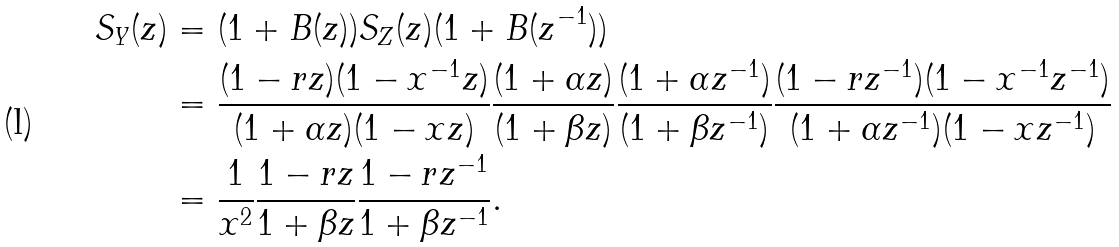<formula> <loc_0><loc_0><loc_500><loc_500>S _ { Y } ( z ) & = ( 1 + B ( z ) ) S _ { Z } ( z ) ( 1 + B ( z ^ { - 1 } ) ) \\ & = \frac { ( 1 - r z ) ( 1 - x ^ { - 1 } z ) } { ( 1 + \alpha z ) ( 1 - x z ) } \frac { ( 1 + \alpha z ) } { ( 1 + \beta z ) } \frac { ( 1 + \alpha z ^ { - 1 } ) } { ( 1 + \beta z ^ { - 1 } ) } \frac { ( 1 - r z ^ { - 1 } ) ( 1 - x ^ { - 1 } z ^ { - 1 } ) } { ( 1 + \alpha z ^ { - 1 } ) ( 1 - x z ^ { - 1 } ) } \\ & = \frac { 1 } { x ^ { 2 } } \frac { 1 - r z } { 1 + \beta z } \frac { 1 - r z ^ { - 1 } } { 1 + \beta z ^ { - 1 } } .</formula> 